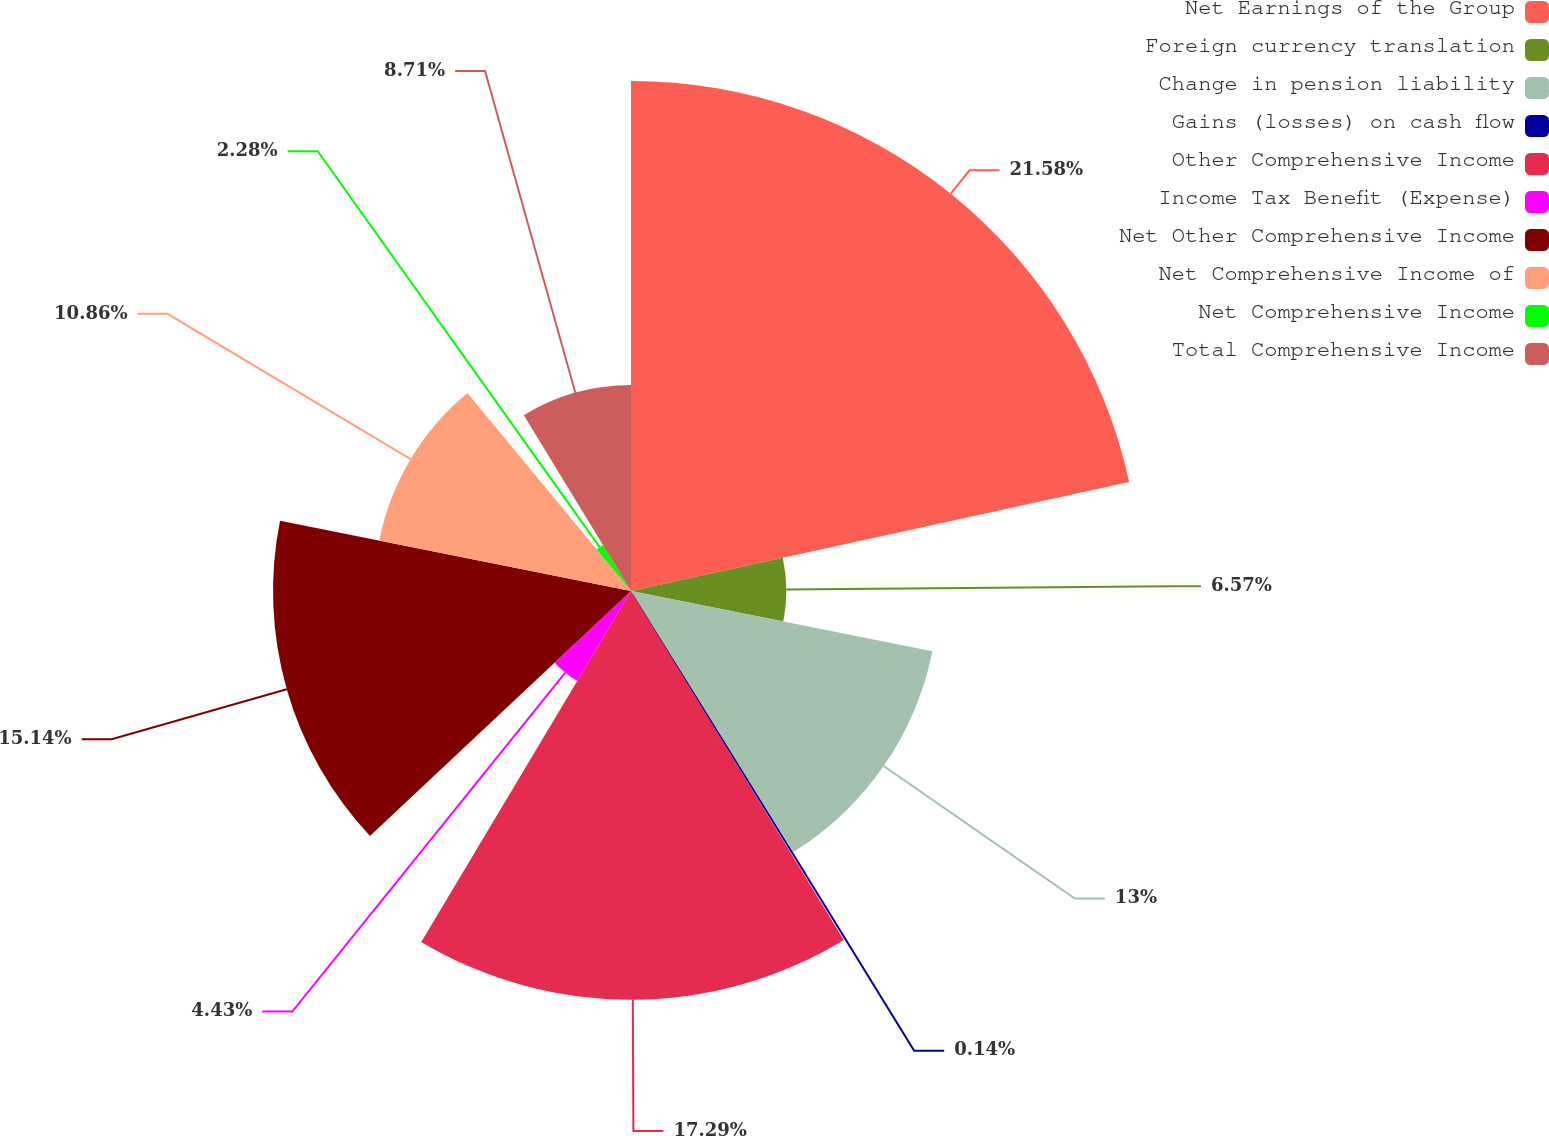Convert chart to OTSL. <chart><loc_0><loc_0><loc_500><loc_500><pie_chart><fcel>Net Earnings of the Group<fcel>Foreign currency translation<fcel>Change in pension liability<fcel>Gains (losses) on cash flow<fcel>Other Comprehensive Income<fcel>Income Tax Benefit (Expense)<fcel>Net Other Comprehensive Income<fcel>Net Comprehensive Income of<fcel>Net Comprehensive Income<fcel>Total Comprehensive Income<nl><fcel>21.57%<fcel>6.57%<fcel>13.0%<fcel>0.14%<fcel>17.29%<fcel>4.43%<fcel>15.14%<fcel>10.86%<fcel>2.28%<fcel>8.71%<nl></chart> 